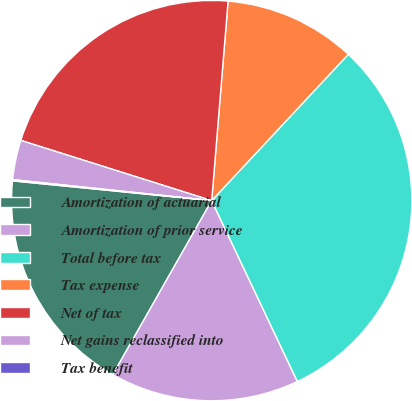Convert chart to OTSL. <chart><loc_0><loc_0><loc_500><loc_500><pie_chart><fcel>Amortization of actuarial<fcel>Amortization of prior service<fcel>Total before tax<fcel>Tax expense<fcel>Net of tax<fcel>Net gains reclassified into<fcel>Tax benefit<nl><fcel>18.35%<fcel>15.26%<fcel>31.0%<fcel>10.65%<fcel>21.44%<fcel>3.19%<fcel>0.1%<nl></chart> 